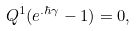Convert formula to latex. <formula><loc_0><loc_0><loc_500><loc_500>Q ^ { 1 } ( e ^ { . \hbar { \gamma } } - 1 ) = 0 ,</formula> 